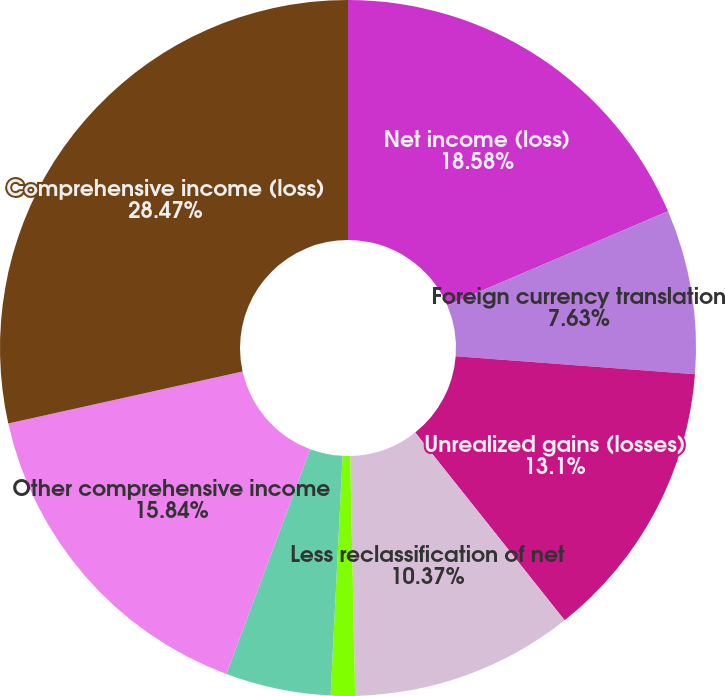Convert chart to OTSL. <chart><loc_0><loc_0><loc_500><loc_500><pie_chart><fcel>Net income (loss)<fcel>Foreign currency translation<fcel>Unrealized gains (losses)<fcel>Less reclassification of net<fcel>Net unrealized gains (losses)<fcel>Net activity of terminated<fcel>Other comprehensive income<fcel>Comprehensive income (loss)<nl><fcel>18.58%<fcel>7.63%<fcel>13.1%<fcel>10.37%<fcel>1.12%<fcel>4.89%<fcel>15.84%<fcel>28.48%<nl></chart> 